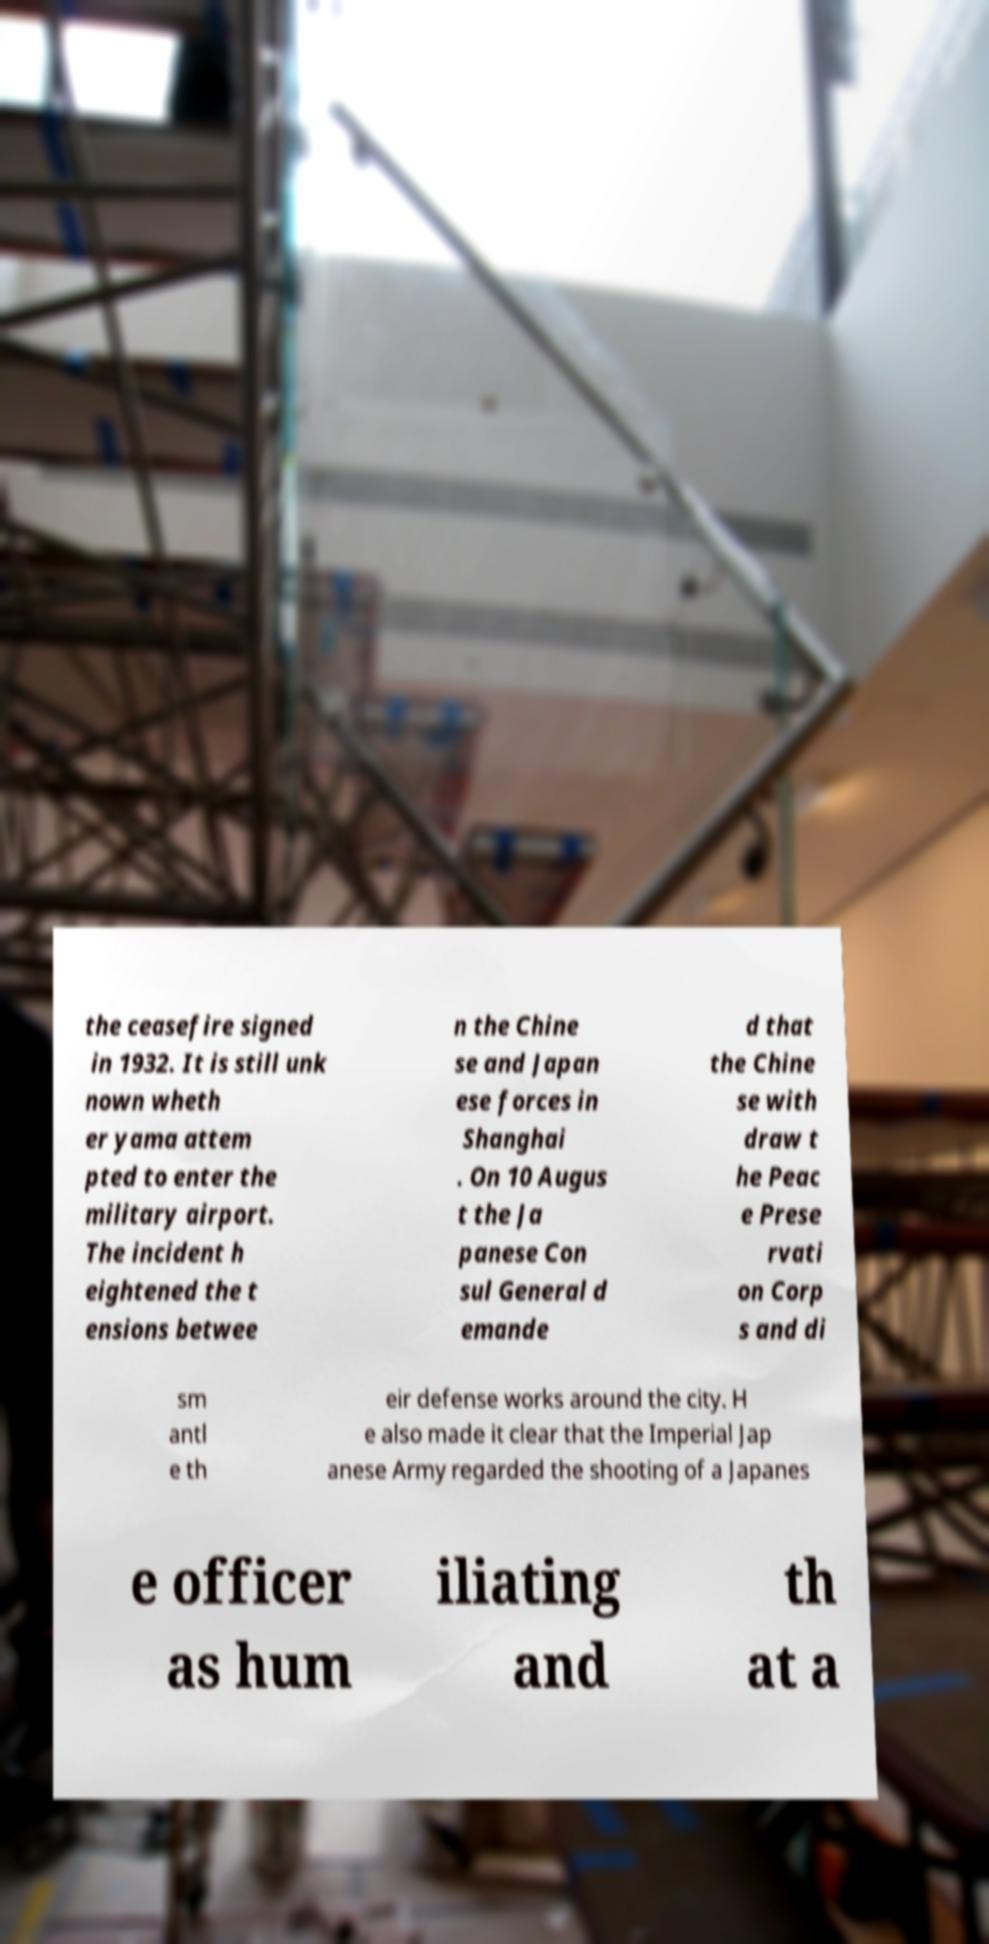I need the written content from this picture converted into text. Can you do that? the ceasefire signed in 1932. It is still unk nown wheth er yama attem pted to enter the military airport. The incident h eightened the t ensions betwee n the Chine se and Japan ese forces in Shanghai . On 10 Augus t the Ja panese Con sul General d emande d that the Chine se with draw t he Peac e Prese rvati on Corp s and di sm antl e th eir defense works around the city. H e also made it clear that the Imperial Jap anese Army regarded the shooting of a Japanes e officer as hum iliating and th at a 